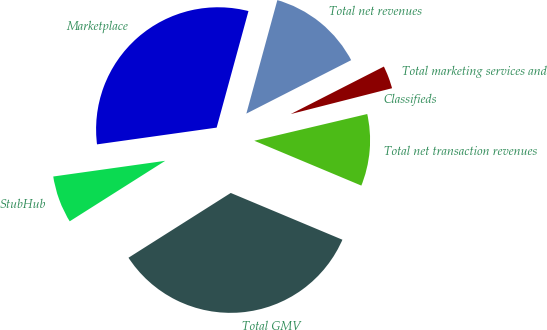Convert chart. <chart><loc_0><loc_0><loc_500><loc_500><pie_chart><fcel>Marketplace<fcel>StubHub<fcel>Total GMV<fcel>Total net transaction revenues<fcel>Classifieds<fcel>Total marketing services and<fcel>Total net revenues<nl><fcel>31.46%<fcel>6.77%<fcel>34.7%<fcel>10.01%<fcel>0.28%<fcel>3.53%<fcel>13.25%<nl></chart> 